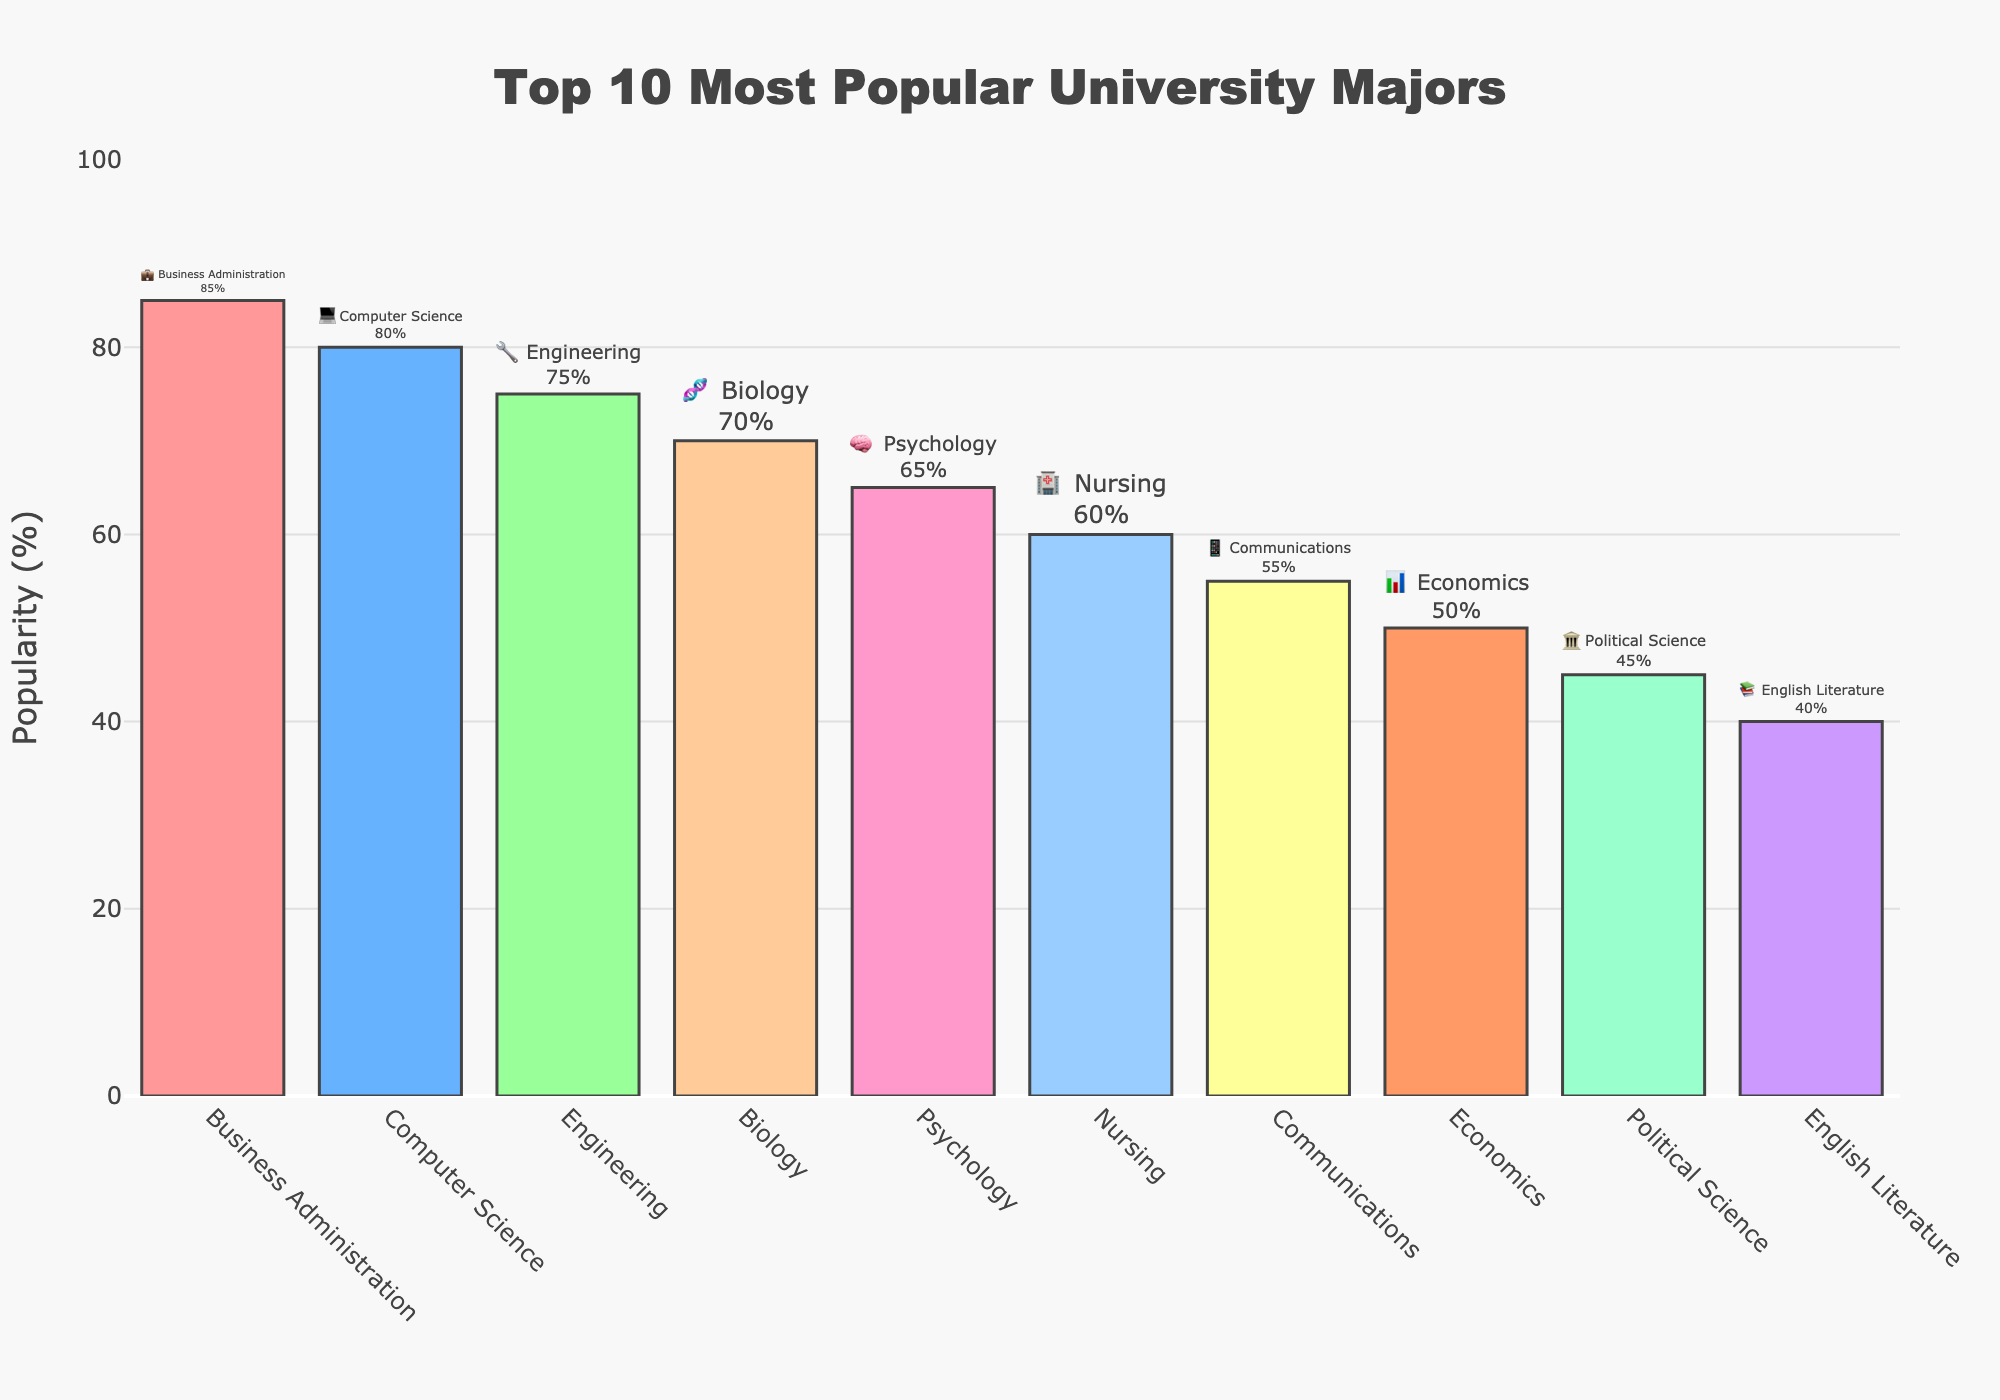what is the most popular university major among high school graduates? Looking at the top of the bars, the major with the highest popularity percentage is Business Administration with 85%.
Answer: Business Administration which major has a 70% popularity? By checking the height of each bar and the labels, Biology has a 70% popularity.
Answer: Biology how many majors have a popularity greater than 60%? The bars for Business Administration, Computer Science, Engineering, Biology, Psychology, and Nursing are all greater than 60%, totaling 6 majors.
Answer: 6 what is the popularity difference between the top two majors? The popularity of Business Administration is 85% and Computer Science is 80%. The difference is 85% - 80% = 5%.
Answer: 5% what is the combined popularity of the least three popular majors? The popularity percentages of Political Science (45%), English Literature (40%), and Economics (50%) add up to 45% + 40% + 50% = 135%.
Answer: 135% which major is more popular: Psychology or Communications? Comparing the heights of the bars for Psychology (65%) and Communication (55%), Psychology is more popular.
Answer: Psychology is the popularity of Nursing higher than Economics? Nursing has a popularity of 60%, while Economics has a popularity of 50%. Therefore, Nursing is more popular.
Answer: Yes which emoji represents the major with the third highest popularity? The third highest popularity is for Engineering which is represented by the 🔧 emoji.
Answer: 🔧 what is the average popularity of the top five majors? The top five majors are Business Administration (85%), Computer Science (80%), Engineering (75%), Biology (70%), and Psychology (65%). The average is (85% + 80% + 75% + 70% + 65%) / 5 = 75%.
Answer: 75% what is the color of the bar representing Computer Science? The bar representing Computer Science is the second one from the left and is colored blue.
Answer: blue 